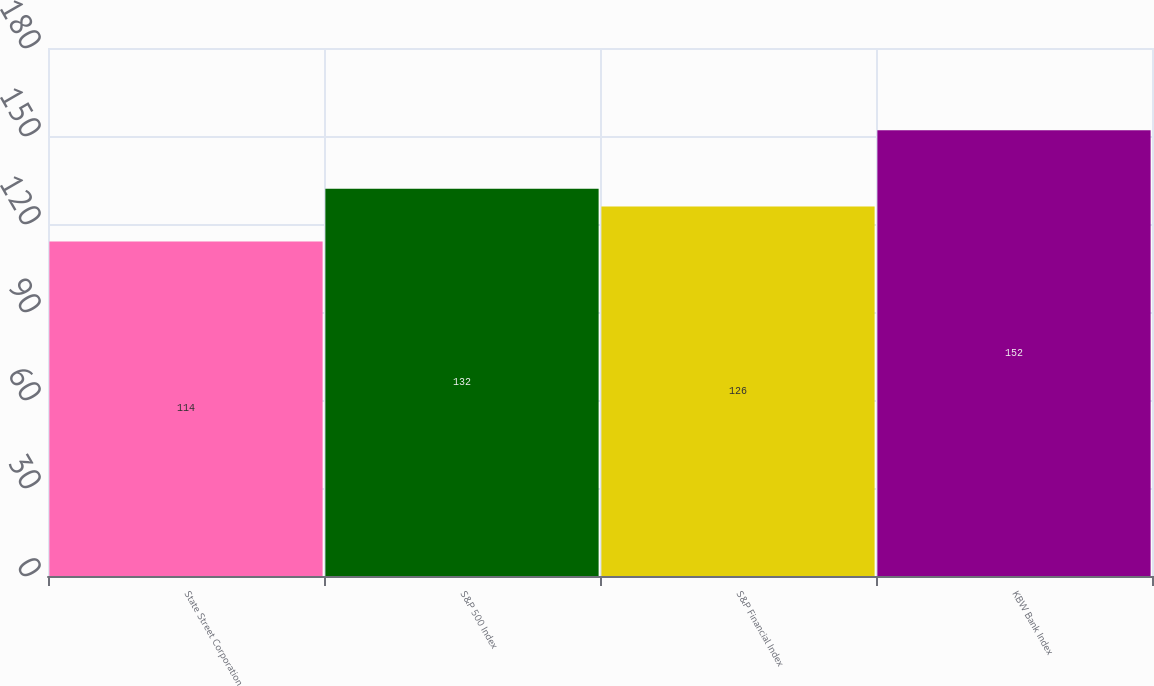<chart> <loc_0><loc_0><loc_500><loc_500><bar_chart><fcel>State Street Corporation<fcel>S&P 500 Index<fcel>S&P Financial Index<fcel>KBW Bank Index<nl><fcel>114<fcel>132<fcel>126<fcel>152<nl></chart> 